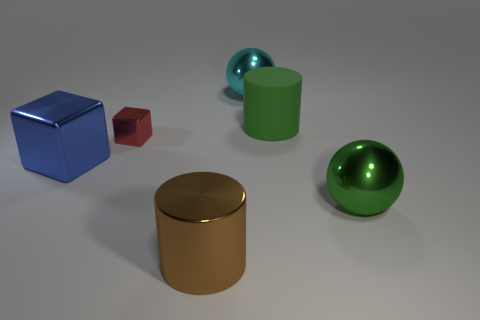How many other things are there of the same material as the green ball?
Your response must be concise. 4. There is a big object on the left side of the red metallic cube; is it the same color as the big shiny thing behind the big blue block?
Provide a succinct answer. No. There is a large metallic object that is to the right of the shiny object that is behind the rubber cylinder; what shape is it?
Your answer should be compact. Sphere. What number of other objects are there of the same color as the matte object?
Provide a succinct answer. 1. Do the big sphere that is to the right of the cyan thing and the big brown cylinder on the left side of the big green metal object have the same material?
Your answer should be very brief. Yes. There is a green thing behind the small metallic block; what size is it?
Your answer should be very brief. Large. There is a green object that is the same shape as the big cyan shiny object; what is it made of?
Your answer should be very brief. Metal. Is there any other thing that has the same size as the brown thing?
Ensure brevity in your answer.  Yes. What is the shape of the thing on the right side of the green matte cylinder?
Ensure brevity in your answer.  Sphere. How many other big blue metal objects have the same shape as the blue thing?
Keep it short and to the point. 0. 